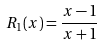<formula> <loc_0><loc_0><loc_500><loc_500>R _ { 1 } ( x ) = \frac { x - 1 } { x + 1 }</formula> 